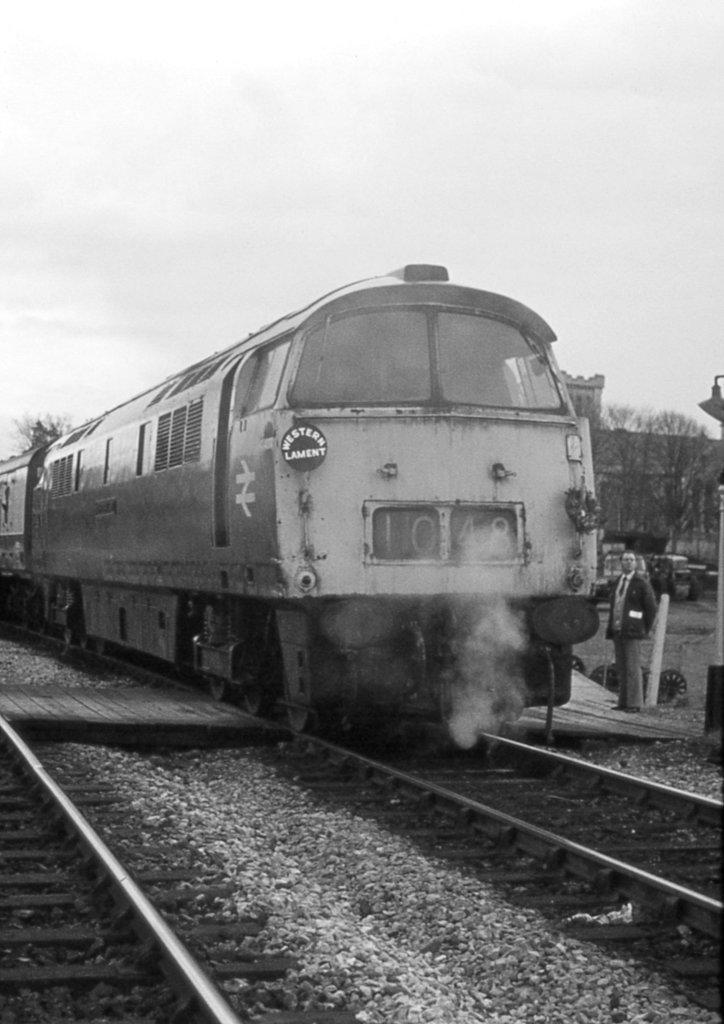How would you summarize this image in a sentence or two? In this image we can see a train on the track. In the background there are trees, building and sky. At the bottom we can see railway tracks. 